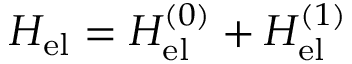<formula> <loc_0><loc_0><loc_500><loc_500>H _ { e l } = H _ { e l } ^ { ( 0 ) } + H _ { e l } ^ { ( 1 ) }</formula> 